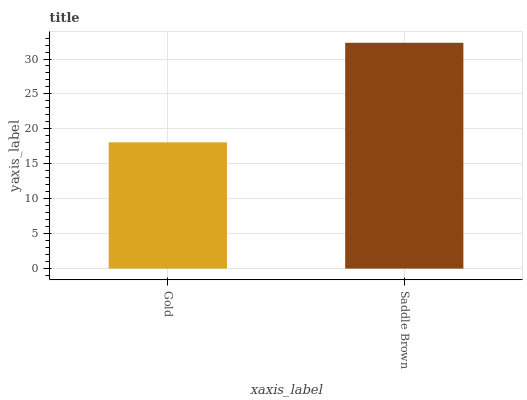Is Saddle Brown the minimum?
Answer yes or no. No. Is Saddle Brown greater than Gold?
Answer yes or no. Yes. Is Gold less than Saddle Brown?
Answer yes or no. Yes. Is Gold greater than Saddle Brown?
Answer yes or no. No. Is Saddle Brown less than Gold?
Answer yes or no. No. Is Saddle Brown the high median?
Answer yes or no. Yes. Is Gold the low median?
Answer yes or no. Yes. Is Gold the high median?
Answer yes or no. No. Is Saddle Brown the low median?
Answer yes or no. No. 